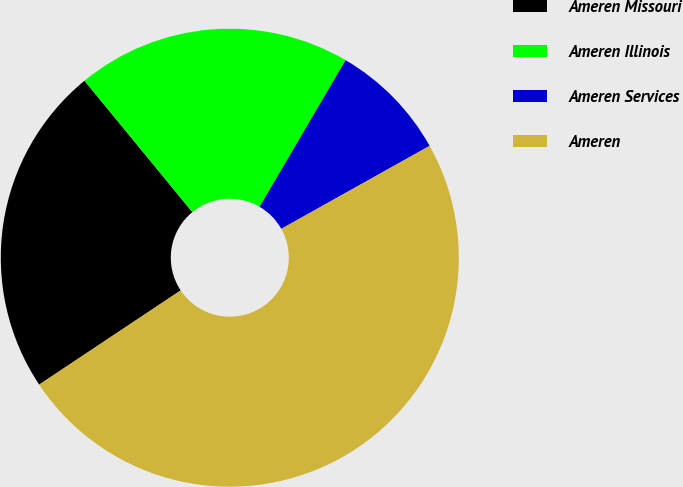Convert chart to OTSL. <chart><loc_0><loc_0><loc_500><loc_500><pie_chart><fcel>Ameren Missouri<fcel>Ameren Illinois<fcel>Ameren Services<fcel>Ameren<nl><fcel>23.41%<fcel>19.38%<fcel>8.44%<fcel>48.77%<nl></chart> 